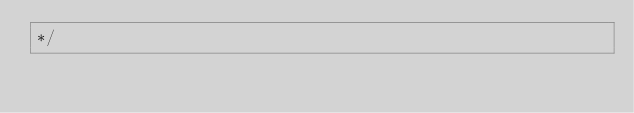Convert code to text. <code><loc_0><loc_0><loc_500><loc_500><_CSS_>*/</code> 